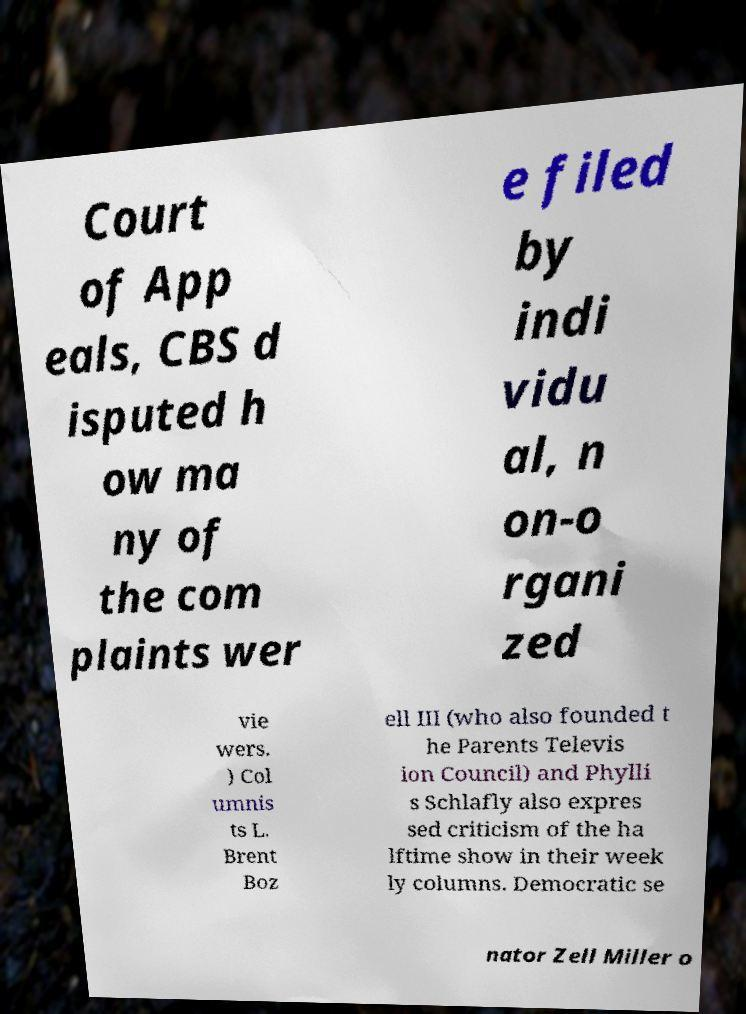For documentation purposes, I need the text within this image transcribed. Could you provide that? Court of App eals, CBS d isputed h ow ma ny of the com plaints wer e filed by indi vidu al, n on-o rgani zed vie wers. ) Col umnis ts L. Brent Boz ell III (who also founded t he Parents Televis ion Council) and Phylli s Schlafly also expres sed criticism of the ha lftime show in their week ly columns. Democratic se nator Zell Miller o 